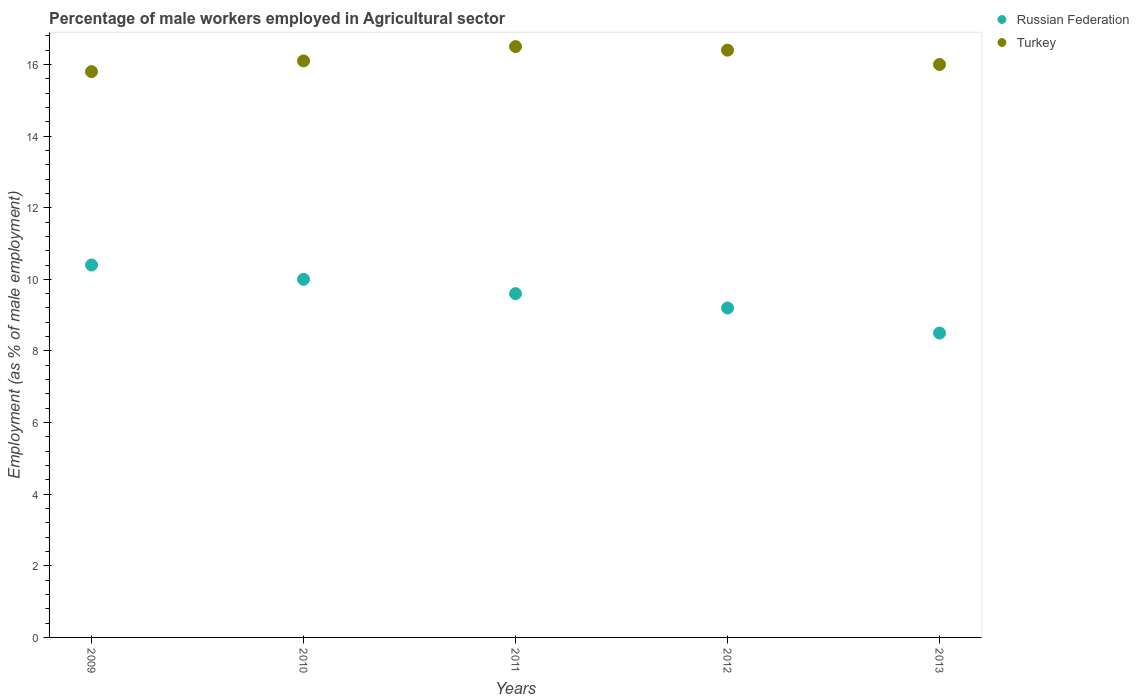Across all years, what is the minimum percentage of male workers employed in Agricultural sector in Turkey?
Provide a succinct answer. 15.8. In which year was the percentage of male workers employed in Agricultural sector in Russian Federation minimum?
Your answer should be very brief. 2013. What is the total percentage of male workers employed in Agricultural sector in Turkey in the graph?
Your response must be concise. 80.8. What is the difference between the percentage of male workers employed in Agricultural sector in Russian Federation in 2009 and that in 2010?
Your response must be concise. 0.4. What is the difference between the percentage of male workers employed in Agricultural sector in Turkey in 2013 and the percentage of male workers employed in Agricultural sector in Russian Federation in 2010?
Provide a succinct answer. 6. What is the average percentage of male workers employed in Agricultural sector in Turkey per year?
Offer a very short reply. 16.16. In the year 2012, what is the difference between the percentage of male workers employed in Agricultural sector in Russian Federation and percentage of male workers employed in Agricultural sector in Turkey?
Your answer should be compact. -7.2. In how many years, is the percentage of male workers employed in Agricultural sector in Turkey greater than 13.6 %?
Provide a short and direct response. 5. What is the ratio of the percentage of male workers employed in Agricultural sector in Turkey in 2010 to that in 2013?
Provide a short and direct response. 1.01. Is the difference between the percentage of male workers employed in Agricultural sector in Russian Federation in 2010 and 2012 greater than the difference between the percentage of male workers employed in Agricultural sector in Turkey in 2010 and 2012?
Provide a short and direct response. Yes. What is the difference between the highest and the second highest percentage of male workers employed in Agricultural sector in Russian Federation?
Offer a very short reply. 0.4. What is the difference between the highest and the lowest percentage of male workers employed in Agricultural sector in Russian Federation?
Make the answer very short. 1.9. In how many years, is the percentage of male workers employed in Agricultural sector in Turkey greater than the average percentage of male workers employed in Agricultural sector in Turkey taken over all years?
Provide a succinct answer. 2. Is the sum of the percentage of male workers employed in Agricultural sector in Russian Federation in 2010 and 2011 greater than the maximum percentage of male workers employed in Agricultural sector in Turkey across all years?
Make the answer very short. Yes. Does the percentage of male workers employed in Agricultural sector in Russian Federation monotonically increase over the years?
Provide a succinct answer. No. How many years are there in the graph?
Provide a short and direct response. 5. What is the difference between two consecutive major ticks on the Y-axis?
Provide a short and direct response. 2. Are the values on the major ticks of Y-axis written in scientific E-notation?
Ensure brevity in your answer.  No. Does the graph contain grids?
Provide a short and direct response. No. Where does the legend appear in the graph?
Your response must be concise. Top right. What is the title of the graph?
Make the answer very short. Percentage of male workers employed in Agricultural sector. What is the label or title of the X-axis?
Your answer should be very brief. Years. What is the label or title of the Y-axis?
Give a very brief answer. Employment (as % of male employment). What is the Employment (as % of male employment) of Russian Federation in 2009?
Provide a succinct answer. 10.4. What is the Employment (as % of male employment) in Turkey in 2009?
Provide a succinct answer. 15.8. What is the Employment (as % of male employment) in Russian Federation in 2010?
Ensure brevity in your answer.  10. What is the Employment (as % of male employment) of Turkey in 2010?
Offer a terse response. 16.1. What is the Employment (as % of male employment) in Russian Federation in 2011?
Offer a terse response. 9.6. What is the Employment (as % of male employment) in Russian Federation in 2012?
Your answer should be compact. 9.2. What is the Employment (as % of male employment) in Turkey in 2012?
Offer a terse response. 16.4. What is the Employment (as % of male employment) of Turkey in 2013?
Keep it short and to the point. 16. Across all years, what is the maximum Employment (as % of male employment) in Russian Federation?
Your answer should be very brief. 10.4. Across all years, what is the minimum Employment (as % of male employment) of Turkey?
Your answer should be very brief. 15.8. What is the total Employment (as % of male employment) in Russian Federation in the graph?
Give a very brief answer. 47.7. What is the total Employment (as % of male employment) in Turkey in the graph?
Offer a very short reply. 80.8. What is the difference between the Employment (as % of male employment) in Russian Federation in 2009 and that in 2010?
Offer a very short reply. 0.4. What is the difference between the Employment (as % of male employment) in Russian Federation in 2009 and that in 2013?
Give a very brief answer. 1.9. What is the difference between the Employment (as % of male employment) in Turkey in 2009 and that in 2013?
Your response must be concise. -0.2. What is the difference between the Employment (as % of male employment) in Turkey in 2010 and that in 2011?
Make the answer very short. -0.4. What is the difference between the Employment (as % of male employment) in Russian Federation in 2010 and that in 2012?
Your answer should be very brief. 0.8. What is the difference between the Employment (as % of male employment) of Turkey in 2010 and that in 2012?
Ensure brevity in your answer.  -0.3. What is the difference between the Employment (as % of male employment) of Turkey in 2010 and that in 2013?
Your response must be concise. 0.1. What is the difference between the Employment (as % of male employment) in Russian Federation in 2011 and that in 2012?
Your response must be concise. 0.4. What is the difference between the Employment (as % of male employment) of Turkey in 2011 and that in 2012?
Keep it short and to the point. 0.1. What is the difference between the Employment (as % of male employment) of Russian Federation in 2011 and that in 2013?
Keep it short and to the point. 1.1. What is the difference between the Employment (as % of male employment) in Russian Federation in 2012 and that in 2013?
Provide a succinct answer. 0.7. What is the difference between the Employment (as % of male employment) in Russian Federation in 2010 and the Employment (as % of male employment) in Turkey in 2011?
Your answer should be compact. -6.5. What is the difference between the Employment (as % of male employment) in Russian Federation in 2010 and the Employment (as % of male employment) in Turkey in 2012?
Provide a succinct answer. -6.4. What is the difference between the Employment (as % of male employment) of Russian Federation in 2011 and the Employment (as % of male employment) of Turkey in 2013?
Offer a terse response. -6.4. What is the average Employment (as % of male employment) in Russian Federation per year?
Ensure brevity in your answer.  9.54. What is the average Employment (as % of male employment) of Turkey per year?
Ensure brevity in your answer.  16.16. In the year 2009, what is the difference between the Employment (as % of male employment) of Russian Federation and Employment (as % of male employment) of Turkey?
Offer a terse response. -5.4. In the year 2010, what is the difference between the Employment (as % of male employment) of Russian Federation and Employment (as % of male employment) of Turkey?
Your answer should be compact. -6.1. In the year 2011, what is the difference between the Employment (as % of male employment) of Russian Federation and Employment (as % of male employment) of Turkey?
Keep it short and to the point. -6.9. What is the ratio of the Employment (as % of male employment) in Russian Federation in 2009 to that in 2010?
Give a very brief answer. 1.04. What is the ratio of the Employment (as % of male employment) of Turkey in 2009 to that in 2010?
Offer a terse response. 0.98. What is the ratio of the Employment (as % of male employment) in Turkey in 2009 to that in 2011?
Give a very brief answer. 0.96. What is the ratio of the Employment (as % of male employment) in Russian Federation in 2009 to that in 2012?
Make the answer very short. 1.13. What is the ratio of the Employment (as % of male employment) of Turkey in 2009 to that in 2012?
Your answer should be compact. 0.96. What is the ratio of the Employment (as % of male employment) in Russian Federation in 2009 to that in 2013?
Ensure brevity in your answer.  1.22. What is the ratio of the Employment (as % of male employment) of Turkey in 2009 to that in 2013?
Your response must be concise. 0.99. What is the ratio of the Employment (as % of male employment) in Russian Federation in 2010 to that in 2011?
Your answer should be very brief. 1.04. What is the ratio of the Employment (as % of male employment) of Turkey in 2010 to that in 2011?
Give a very brief answer. 0.98. What is the ratio of the Employment (as % of male employment) in Russian Federation in 2010 to that in 2012?
Offer a very short reply. 1.09. What is the ratio of the Employment (as % of male employment) in Turkey in 2010 to that in 2012?
Offer a terse response. 0.98. What is the ratio of the Employment (as % of male employment) of Russian Federation in 2010 to that in 2013?
Your answer should be compact. 1.18. What is the ratio of the Employment (as % of male employment) in Turkey in 2010 to that in 2013?
Offer a terse response. 1.01. What is the ratio of the Employment (as % of male employment) of Russian Federation in 2011 to that in 2012?
Provide a short and direct response. 1.04. What is the ratio of the Employment (as % of male employment) of Turkey in 2011 to that in 2012?
Provide a short and direct response. 1.01. What is the ratio of the Employment (as % of male employment) of Russian Federation in 2011 to that in 2013?
Your response must be concise. 1.13. What is the ratio of the Employment (as % of male employment) of Turkey in 2011 to that in 2013?
Offer a terse response. 1.03. What is the ratio of the Employment (as % of male employment) of Russian Federation in 2012 to that in 2013?
Ensure brevity in your answer.  1.08. What is the ratio of the Employment (as % of male employment) in Turkey in 2012 to that in 2013?
Your answer should be compact. 1.02. 